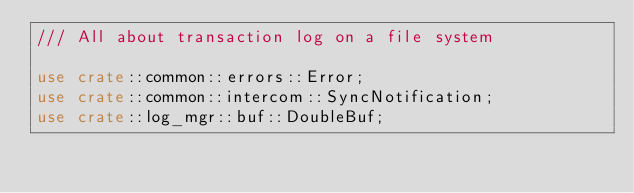<code> <loc_0><loc_0><loc_500><loc_500><_Rust_>/// All about transaction log on a file system

use crate::common::errors::Error;
use crate::common::intercom::SyncNotification;
use crate::log_mgr::buf::DoubleBuf;</code> 